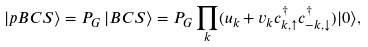<formula> <loc_0><loc_0><loc_500><loc_500>| p B C S \rangle = P _ { G } \, | B C S \rangle = P _ { G } \prod _ { k } ( u _ { k } + v _ { k } c ^ { \dagger } _ { k , \uparrow } c ^ { \dagger } _ { - k , \downarrow } ) | 0 \rangle ,</formula> 